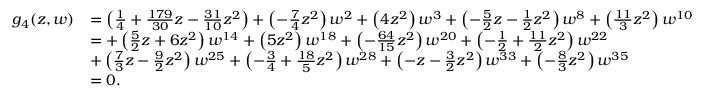<formula> <loc_0><loc_0><loc_500><loc_500>\begin{array} { r l } { g _ { 4 } ( z , w ) } & { = \left ( \frac { 1 } { 4 } + \frac { 1 7 9 } { 3 0 } z - \frac { 3 1 } { 1 0 } z ^ { 2 } \right ) + \left ( - \frac { 7 } { 4 } z ^ { 2 } \right ) w ^ { 2 } + \left ( 4 z ^ { 2 } \right ) w ^ { 3 } + \left ( - \frac { 5 } { 2 } z - \frac { 1 } { 2 } z ^ { 2 } \right ) w ^ { 8 } + \left ( \frac { 1 1 } { 3 } z ^ { 2 } \right ) w ^ { 1 0 } } \\ & { = + \left ( \frac { 5 } { 2 } z + 6 z ^ { 2 } \right ) w ^ { 1 4 } + \left ( 5 z ^ { 2 } \right ) w ^ { 1 8 } + \left ( - \frac { 6 4 } { 1 5 } z ^ { 2 } \right ) w ^ { 2 0 } + \left ( - \frac { 1 } { 2 } + \frac { 1 1 } { 2 } z ^ { 2 } \right ) w ^ { 2 2 } } \\ & { + \left ( \frac { 7 } { 3 } z - \frac { 9 } { 2 } z ^ { 2 } \right ) w ^ { 2 5 } + \left ( - \frac { 3 } { 4 } + \frac { 1 8 } { 5 } z ^ { 2 } \right ) w ^ { 2 8 } + \left ( - z - \frac { 3 } { 2 } z ^ { 2 } \right ) w ^ { 3 3 } + \left ( - \frac { 8 } { 3 } z ^ { 2 } \right ) w ^ { 3 5 } } \\ & { = 0 . } \end{array}</formula> 